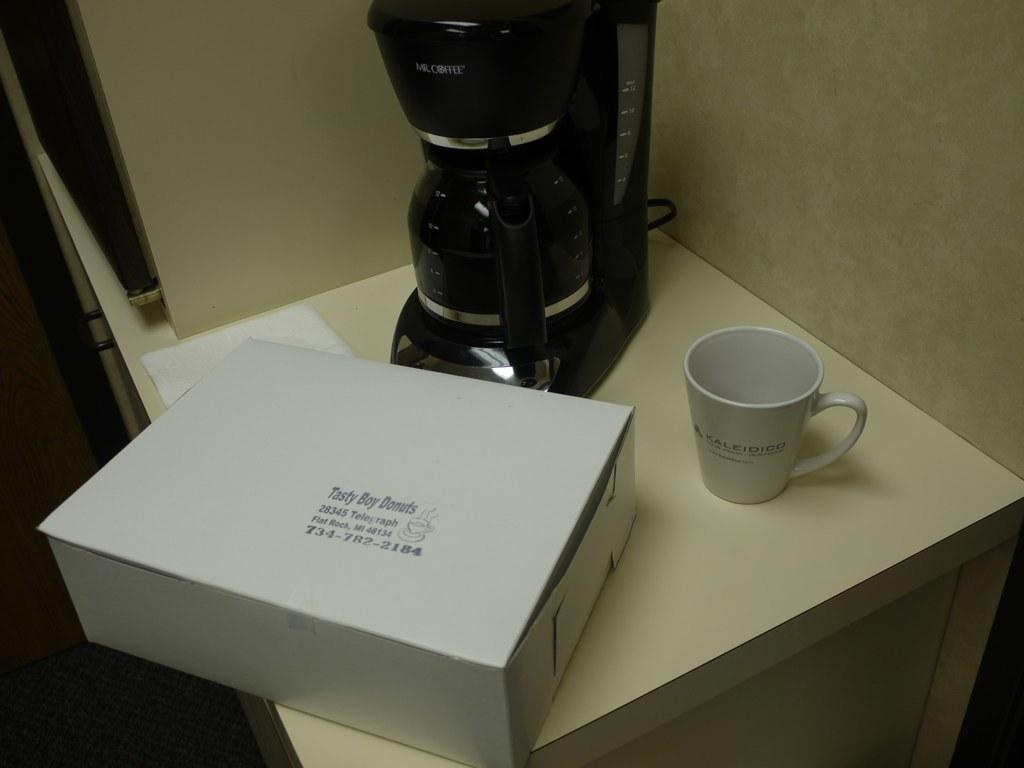<image>
Relay a brief, clear account of the picture shown. A plain white box of Tasty Boy Donuts sits on a table near a coffee maker. 